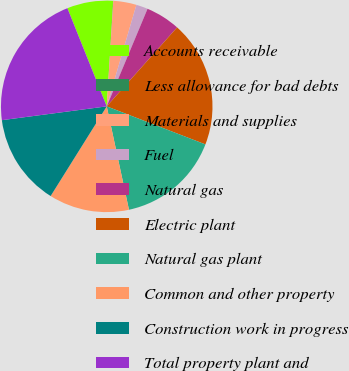Convert chart to OTSL. <chart><loc_0><loc_0><loc_500><loc_500><pie_chart><fcel>Accounts receivable<fcel>Less allowance for bad debts<fcel>Materials and supplies<fcel>Fuel<fcel>Natural gas<fcel>Electric plant<fcel>Natural gas plant<fcel>Common and other property<fcel>Construction work in progress<fcel>Total property plant and<nl><fcel>7.03%<fcel>0.03%<fcel>3.53%<fcel>1.78%<fcel>5.28%<fcel>19.27%<fcel>15.77%<fcel>12.27%<fcel>14.02%<fcel>21.02%<nl></chart> 